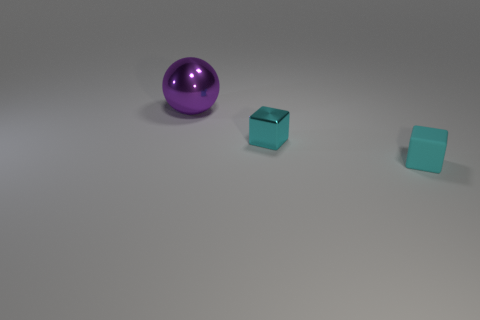How many other things are there of the same size as the ball?
Keep it short and to the point. 0. There is a tiny metallic thing; does it have the same color as the object in front of the small cyan metal thing?
Offer a very short reply. Yes. Are there fewer small cyan rubber things behind the metallic block than cyan things that are behind the tiny cyan rubber block?
Provide a succinct answer. Yes. What is the color of the thing that is both on the left side of the rubber object and in front of the large object?
Offer a very short reply. Cyan. There is a shiny block; is its size the same as the cube in front of the small cyan metal object?
Ensure brevity in your answer.  Yes. There is a large purple thing that is left of the cyan rubber object; what is its shape?
Provide a short and direct response. Sphere. Are there more small cyan things in front of the big sphere than large brown rubber objects?
Offer a very short reply. Yes. How many cyan rubber cubes are on the left side of the object that is behind the metallic object to the right of the purple object?
Make the answer very short. 0. Is the size of the metal thing that is to the right of the big ball the same as the purple object behind the cyan matte object?
Offer a very short reply. No. What material is the small cube that is in front of the cyan thing left of the small rubber cube made of?
Your answer should be compact. Rubber. 